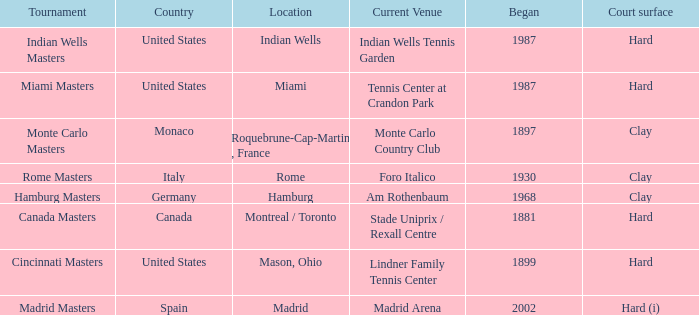In which year was the competition initially conducted in italy? 1930.0. 